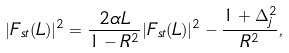Convert formula to latex. <formula><loc_0><loc_0><loc_500><loc_500>| F _ { s t } ( L ) | ^ { 2 } = \frac { 2 \alpha L } { 1 - R ^ { 2 } } | F _ { s t } ( L ) | ^ { 2 } - \frac { 1 + \Delta ^ { 2 } _ { j } } { R ^ { 2 } } ,</formula> 